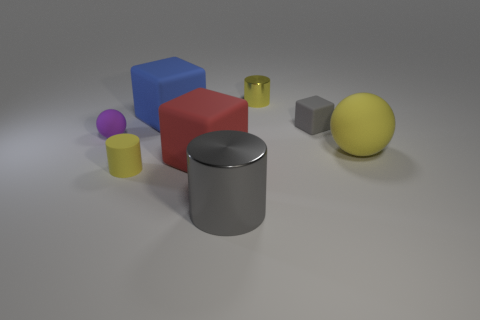How many things are large red matte spheres or big blocks in front of the tiny purple sphere?
Make the answer very short. 1. There is a metallic cylinder that is the same color as the big ball; what size is it?
Give a very brief answer. Small. What shape is the yellow object that is right of the small yellow shiny thing?
Your response must be concise. Sphere. Is the color of the shiny thing to the left of the tiny yellow shiny object the same as the matte cylinder?
Provide a succinct answer. No. There is another tiny object that is the same color as the small shiny thing; what material is it?
Keep it short and to the point. Rubber. There is a ball that is left of the red rubber thing; is it the same size as the tiny gray rubber cube?
Ensure brevity in your answer.  Yes. Are there any matte cubes of the same color as the tiny shiny thing?
Give a very brief answer. No. Are there any big yellow spheres to the left of the tiny yellow cylinder right of the big shiny thing?
Your response must be concise. No. Is there a tiny gray cube made of the same material as the big yellow ball?
Keep it short and to the point. Yes. What is the small yellow cylinder that is behind the large block that is in front of the small matte ball made of?
Offer a terse response. Metal. 